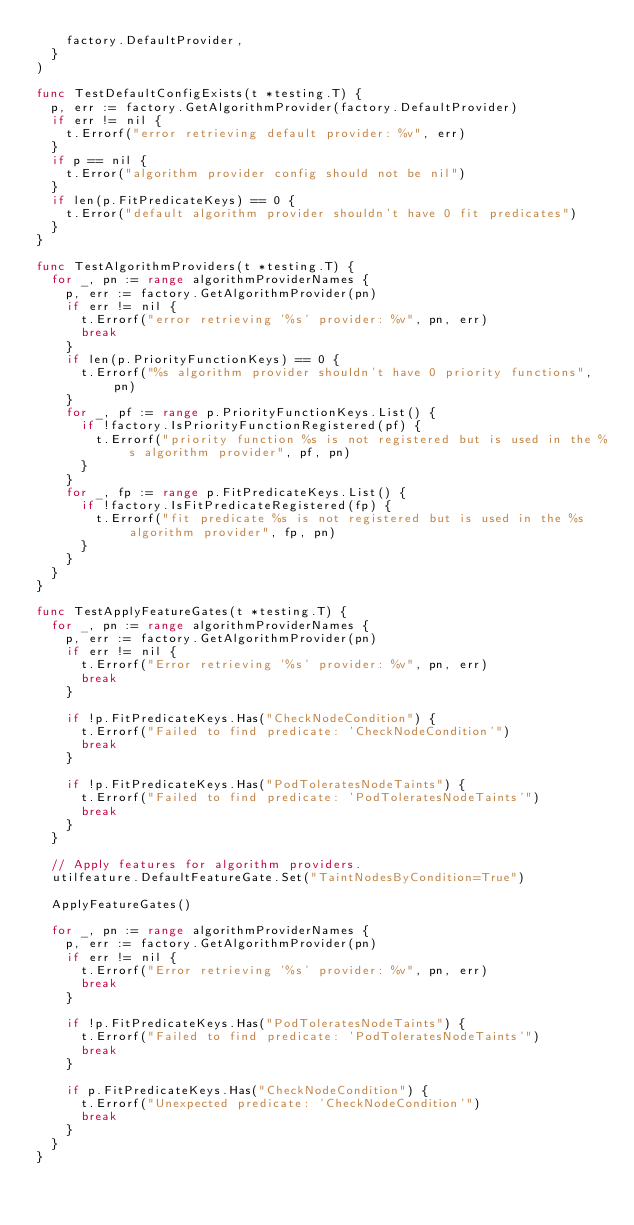<code> <loc_0><loc_0><loc_500><loc_500><_Go_>		factory.DefaultProvider,
	}
)

func TestDefaultConfigExists(t *testing.T) {
	p, err := factory.GetAlgorithmProvider(factory.DefaultProvider)
	if err != nil {
		t.Errorf("error retrieving default provider: %v", err)
	}
	if p == nil {
		t.Error("algorithm provider config should not be nil")
	}
	if len(p.FitPredicateKeys) == 0 {
		t.Error("default algorithm provider shouldn't have 0 fit predicates")
	}
}

func TestAlgorithmProviders(t *testing.T) {
	for _, pn := range algorithmProviderNames {
		p, err := factory.GetAlgorithmProvider(pn)
		if err != nil {
			t.Errorf("error retrieving '%s' provider: %v", pn, err)
			break
		}
		if len(p.PriorityFunctionKeys) == 0 {
			t.Errorf("%s algorithm provider shouldn't have 0 priority functions", pn)
		}
		for _, pf := range p.PriorityFunctionKeys.List() {
			if !factory.IsPriorityFunctionRegistered(pf) {
				t.Errorf("priority function %s is not registered but is used in the %s algorithm provider", pf, pn)
			}
		}
		for _, fp := range p.FitPredicateKeys.List() {
			if !factory.IsFitPredicateRegistered(fp) {
				t.Errorf("fit predicate %s is not registered but is used in the %s algorithm provider", fp, pn)
			}
		}
	}
}

func TestApplyFeatureGates(t *testing.T) {
	for _, pn := range algorithmProviderNames {
		p, err := factory.GetAlgorithmProvider(pn)
		if err != nil {
			t.Errorf("Error retrieving '%s' provider: %v", pn, err)
			break
		}

		if !p.FitPredicateKeys.Has("CheckNodeCondition") {
			t.Errorf("Failed to find predicate: 'CheckNodeCondition'")
			break
		}

		if !p.FitPredicateKeys.Has("PodToleratesNodeTaints") {
			t.Errorf("Failed to find predicate: 'PodToleratesNodeTaints'")
			break
		}
	}

	// Apply features for algorithm providers.
	utilfeature.DefaultFeatureGate.Set("TaintNodesByCondition=True")

	ApplyFeatureGates()

	for _, pn := range algorithmProviderNames {
		p, err := factory.GetAlgorithmProvider(pn)
		if err != nil {
			t.Errorf("Error retrieving '%s' provider: %v", pn, err)
			break
		}

		if !p.FitPredicateKeys.Has("PodToleratesNodeTaints") {
			t.Errorf("Failed to find predicate: 'PodToleratesNodeTaints'")
			break
		}

		if p.FitPredicateKeys.Has("CheckNodeCondition") {
			t.Errorf("Unexpected predicate: 'CheckNodeCondition'")
			break
		}
	}
}
</code> 